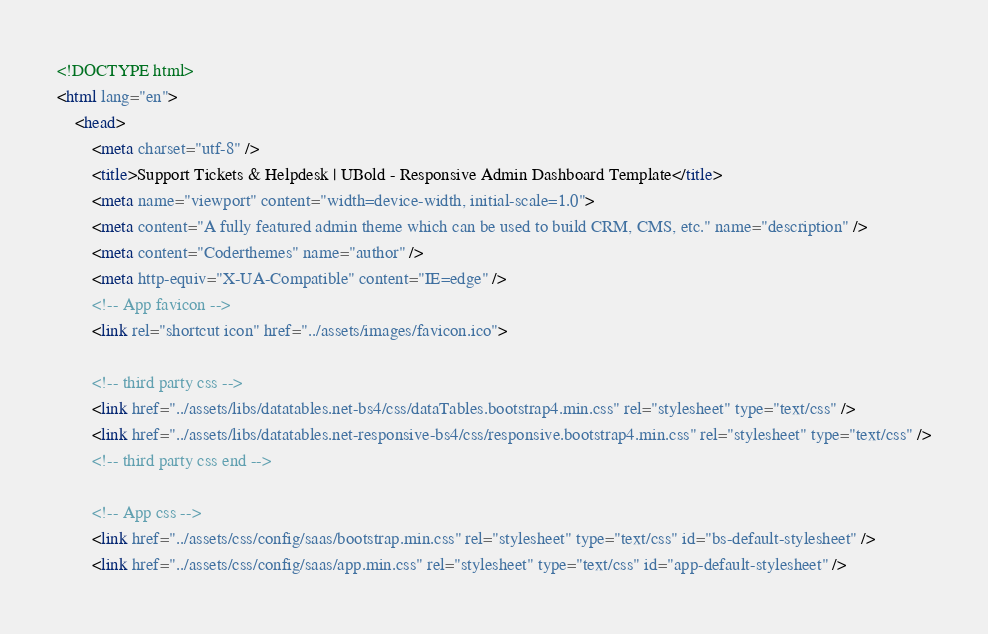<code> <loc_0><loc_0><loc_500><loc_500><_HTML_><!DOCTYPE html>
<html lang="en">
    <head>
        <meta charset="utf-8" />
        <title>Support Tickets & Helpdesk | UBold - Responsive Admin Dashboard Template</title>
        <meta name="viewport" content="width=device-width, initial-scale=1.0">
        <meta content="A fully featured admin theme which can be used to build CRM, CMS, etc." name="description" />
        <meta content="Coderthemes" name="author" />
        <meta http-equiv="X-UA-Compatible" content="IE=edge" />
        <!-- App favicon -->
        <link rel="shortcut icon" href="../assets/images/favicon.ico">

        <!-- third party css -->
        <link href="../assets/libs/datatables.net-bs4/css/dataTables.bootstrap4.min.css" rel="stylesheet" type="text/css" />
        <link href="../assets/libs/datatables.net-responsive-bs4/css/responsive.bootstrap4.min.css" rel="stylesheet" type="text/css" />
        <!-- third party css end -->

		<!-- App css -->
		<link href="../assets/css/config/saas/bootstrap.min.css" rel="stylesheet" type="text/css" id="bs-default-stylesheet" />
		<link href="../assets/css/config/saas/app.min.css" rel="stylesheet" type="text/css" id="app-default-stylesheet" />
</code> 